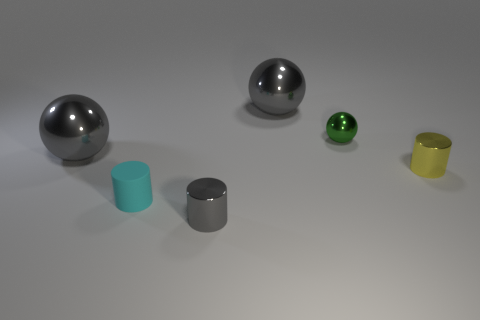How might the lighting in the scene influence our perception of these objects? The lighting in the scene creates soft shadows and highlights on the objects, which help to define their forms and textures. The even lighting conditions provide a clear view, enabling accurate color perception and depth, contributing to the realism of the scene. 